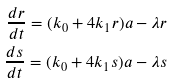<formula> <loc_0><loc_0><loc_500><loc_500>\frac { d r } { d t } = ( k _ { 0 } + 4 k _ { 1 } r ) a - \lambda r \\ \frac { d s } { d t } = ( k _ { 0 } + 4 k _ { 1 } s ) a - \lambda s</formula> 